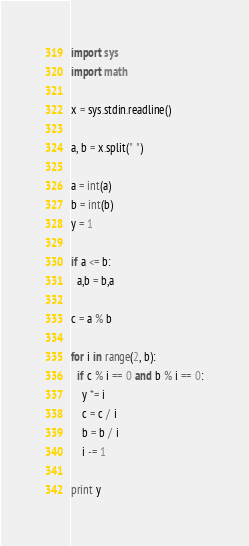Convert code to text. <code><loc_0><loc_0><loc_500><loc_500><_Python_>import sys
import math

x = sys.stdin.readline()

a, b = x.split(" ")

a = int(a)
b = int(b)
y = 1

if a <= b:
  a,b = b,a

c = a % b

for i in range(2, b):
  if c % i == 0 and b % i == 0:
    y *= i
    c = c / i
    b = b / i
    i -= 1

print y</code> 